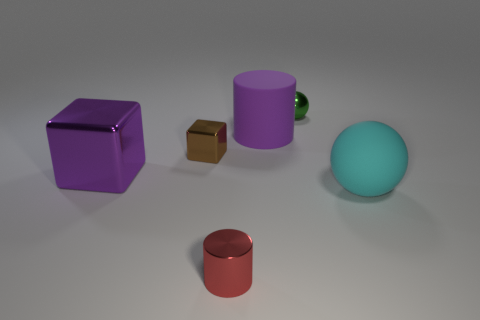What is the shape of the large rubber object that is the same color as the large metallic cube?
Make the answer very short. Cylinder. The metallic object that is the same size as the matte ball is what color?
Offer a very short reply. Purple. Are there any cubes of the same color as the small ball?
Offer a very short reply. No. What size is the purple cube that is the same material as the small green object?
Your response must be concise. Large. There is a shiny block that is the same color as the large cylinder; what is its size?
Provide a short and direct response. Large. How many other objects are the same size as the red metallic object?
Give a very brief answer. 2. There is a sphere behind the purple matte cylinder; what material is it?
Your response must be concise. Metal. What is the shape of the matte object on the left side of the shiny thing that is behind the big rubber thing to the left of the green metallic thing?
Offer a terse response. Cylinder. Does the brown thing have the same size as the red metallic cylinder?
Offer a very short reply. Yes. What number of objects are either small green things or matte things that are in front of the brown shiny thing?
Provide a short and direct response. 2. 